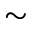<formula> <loc_0><loc_0><loc_500><loc_500>\sim</formula> 